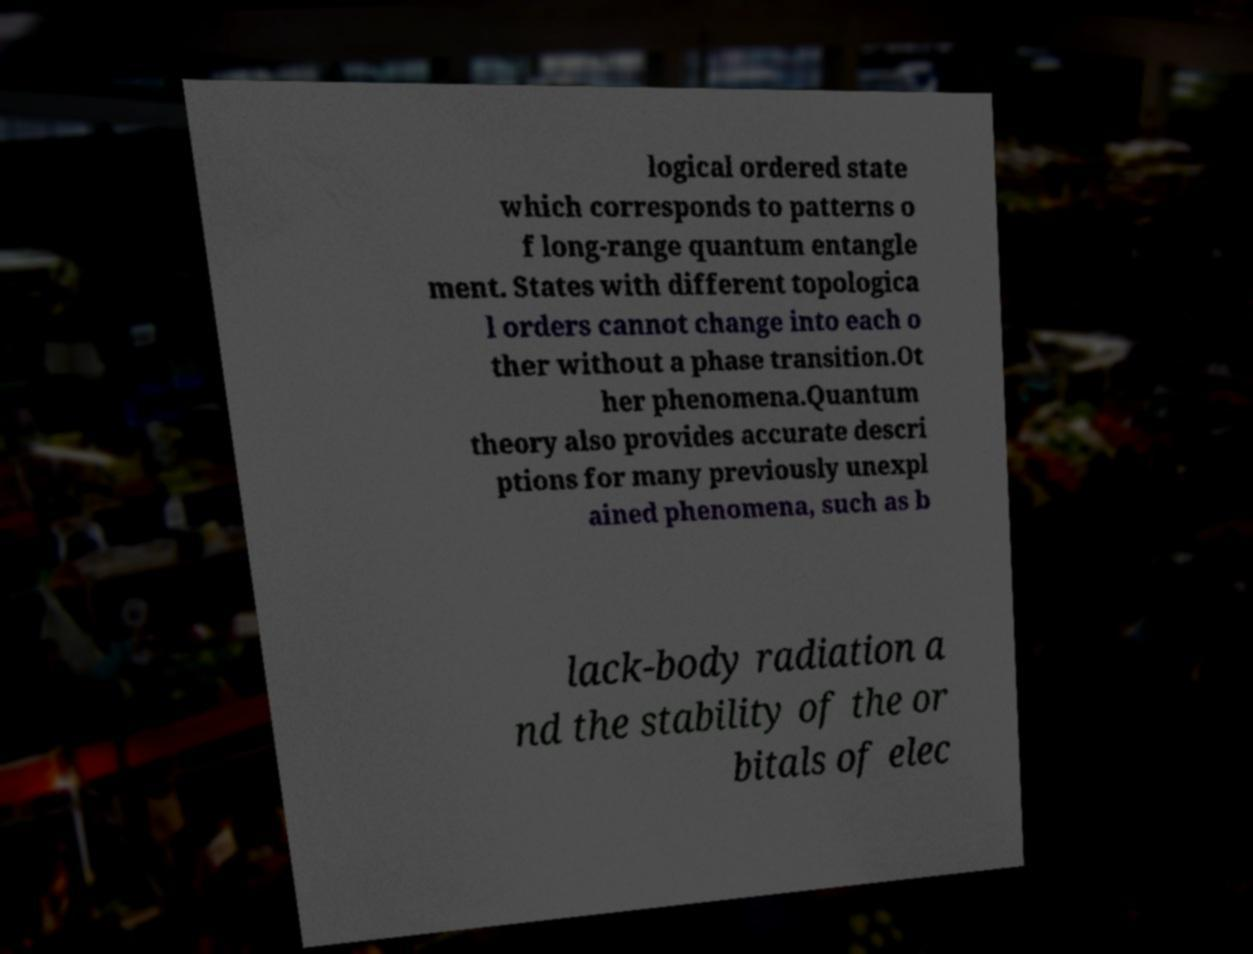Can you read and provide the text displayed in the image?This photo seems to have some interesting text. Can you extract and type it out for me? logical ordered state which corresponds to patterns o f long-range quantum entangle ment. States with different topologica l orders cannot change into each o ther without a phase transition.Ot her phenomena.Quantum theory also provides accurate descri ptions for many previously unexpl ained phenomena, such as b lack-body radiation a nd the stability of the or bitals of elec 